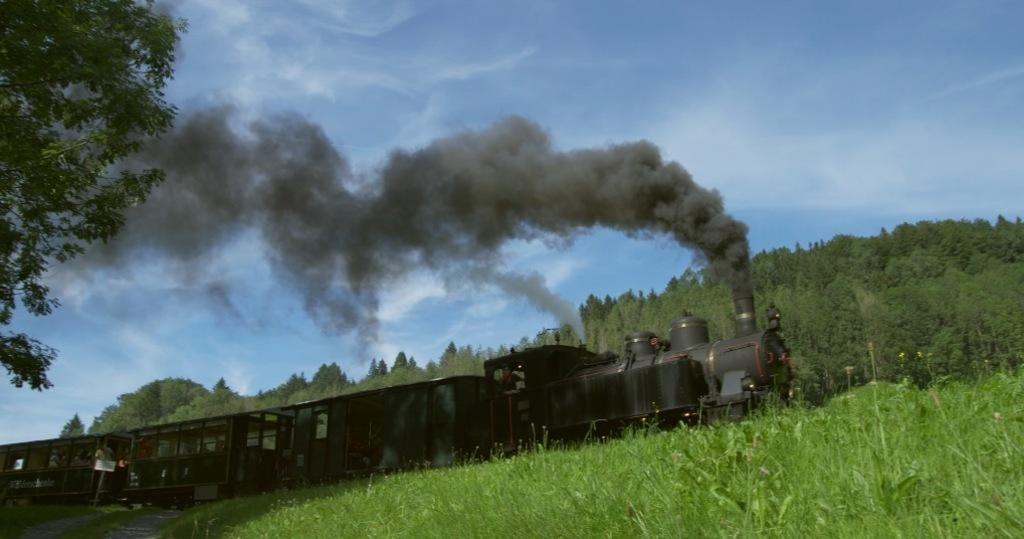What is the main subject of the image? There is a train in the image. Can you describe the surroundings of the train? There is a lot of greenery around the train. What type of clam can be seen on the train in the image? There is no clam present on the train in the image. How many letters are visible on the train in the image? There is no mention of letters on the train in the image. 